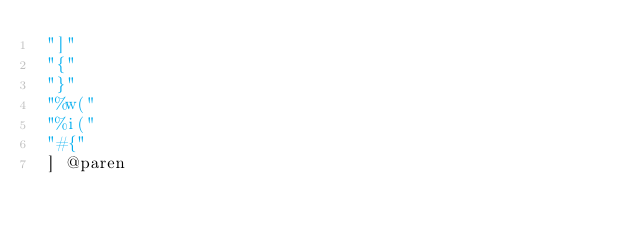<code> <loc_0><loc_0><loc_500><loc_500><_Scheme_> "]"
 "{"
 "}"
 "%w("
 "%i("
 "#{"
 ] @paren
</code> 